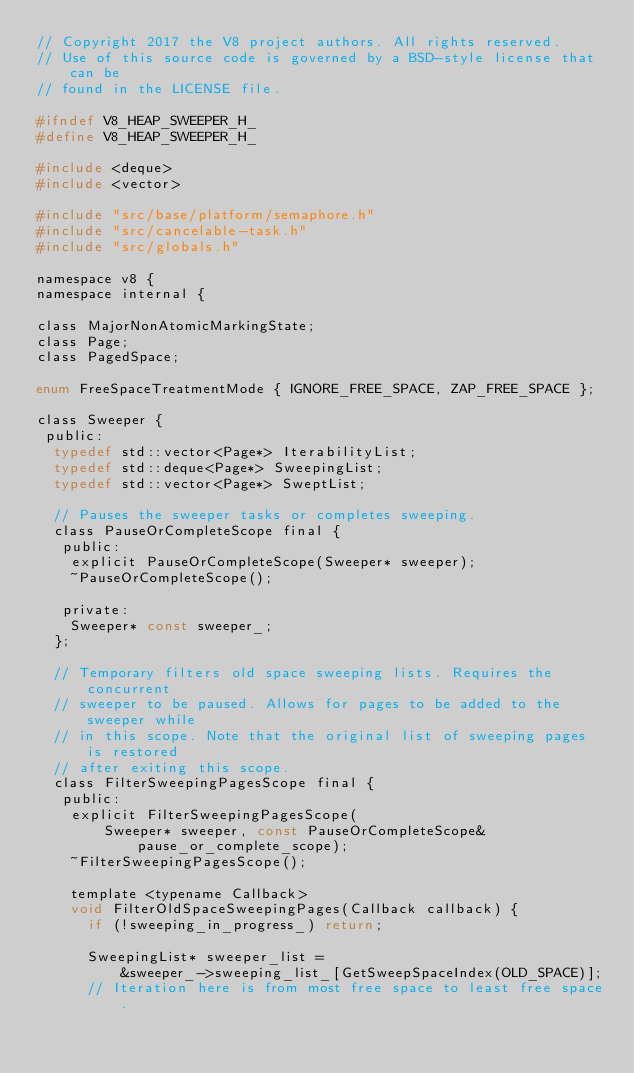Convert code to text. <code><loc_0><loc_0><loc_500><loc_500><_C_>// Copyright 2017 the V8 project authors. All rights reserved.
// Use of this source code is governed by a BSD-style license that can be
// found in the LICENSE file.

#ifndef V8_HEAP_SWEEPER_H_
#define V8_HEAP_SWEEPER_H_

#include <deque>
#include <vector>

#include "src/base/platform/semaphore.h"
#include "src/cancelable-task.h"
#include "src/globals.h"

namespace v8 {
namespace internal {

class MajorNonAtomicMarkingState;
class Page;
class PagedSpace;

enum FreeSpaceTreatmentMode { IGNORE_FREE_SPACE, ZAP_FREE_SPACE };

class Sweeper {
 public:
  typedef std::vector<Page*> IterabilityList;
  typedef std::deque<Page*> SweepingList;
  typedef std::vector<Page*> SweptList;

  // Pauses the sweeper tasks or completes sweeping.
  class PauseOrCompleteScope final {
   public:
    explicit PauseOrCompleteScope(Sweeper* sweeper);
    ~PauseOrCompleteScope();

   private:
    Sweeper* const sweeper_;
  };

  // Temporary filters old space sweeping lists. Requires the concurrent
  // sweeper to be paused. Allows for pages to be added to the sweeper while
  // in this scope. Note that the original list of sweeping pages is restored
  // after exiting this scope.
  class FilterSweepingPagesScope final {
   public:
    explicit FilterSweepingPagesScope(
        Sweeper* sweeper, const PauseOrCompleteScope& pause_or_complete_scope);
    ~FilterSweepingPagesScope();

    template <typename Callback>
    void FilterOldSpaceSweepingPages(Callback callback) {
      if (!sweeping_in_progress_) return;

      SweepingList* sweeper_list =
          &sweeper_->sweeping_list_[GetSweepSpaceIndex(OLD_SPACE)];
      // Iteration here is from most free space to least free space.</code> 